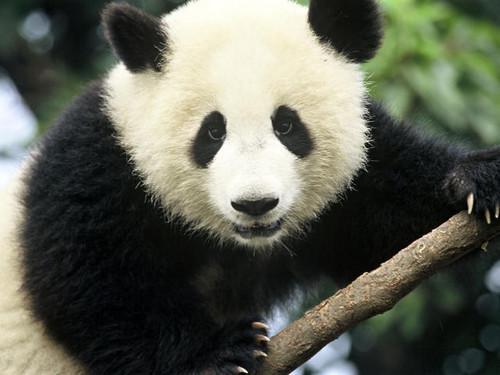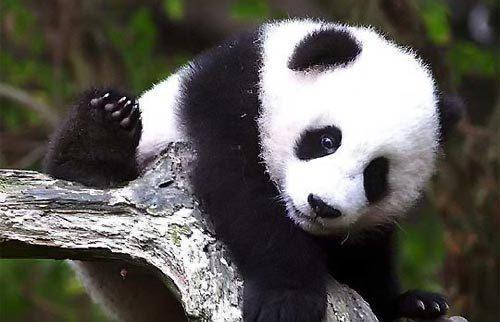The first image is the image on the left, the second image is the image on the right. Evaluate the accuracy of this statement regarding the images: "There are more panda bears in the left image than in the right.". Is it true? Answer yes or no. No. The first image is the image on the left, the second image is the image on the right. Analyze the images presented: Is the assertion "In one of the photos, a panda is eating a bamboo shoot" valid? Answer yes or no. No. 